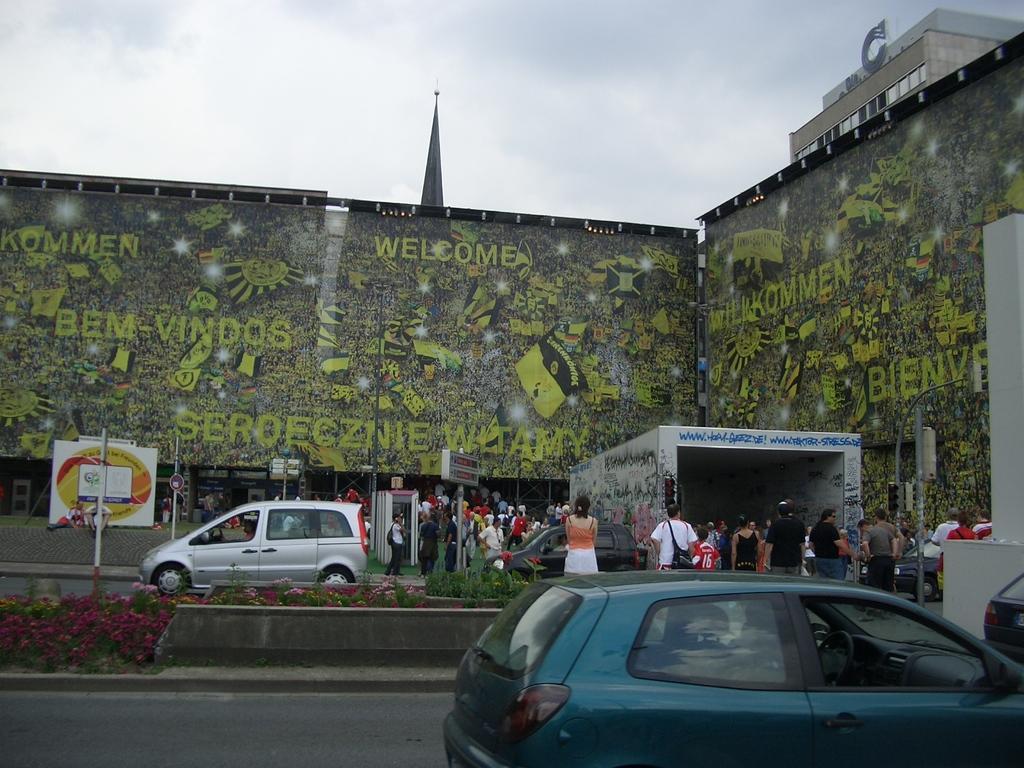In one or two sentences, can you explain what this image depicts? In this image we can see vehicles, plants, people, name boards, poles, wall with painting and other objects. In the background of the image there is a building, sky and an object. At the bottom of the image there is a road and a vehicle. On the right side of the image it looks like a vehicle and an object. 